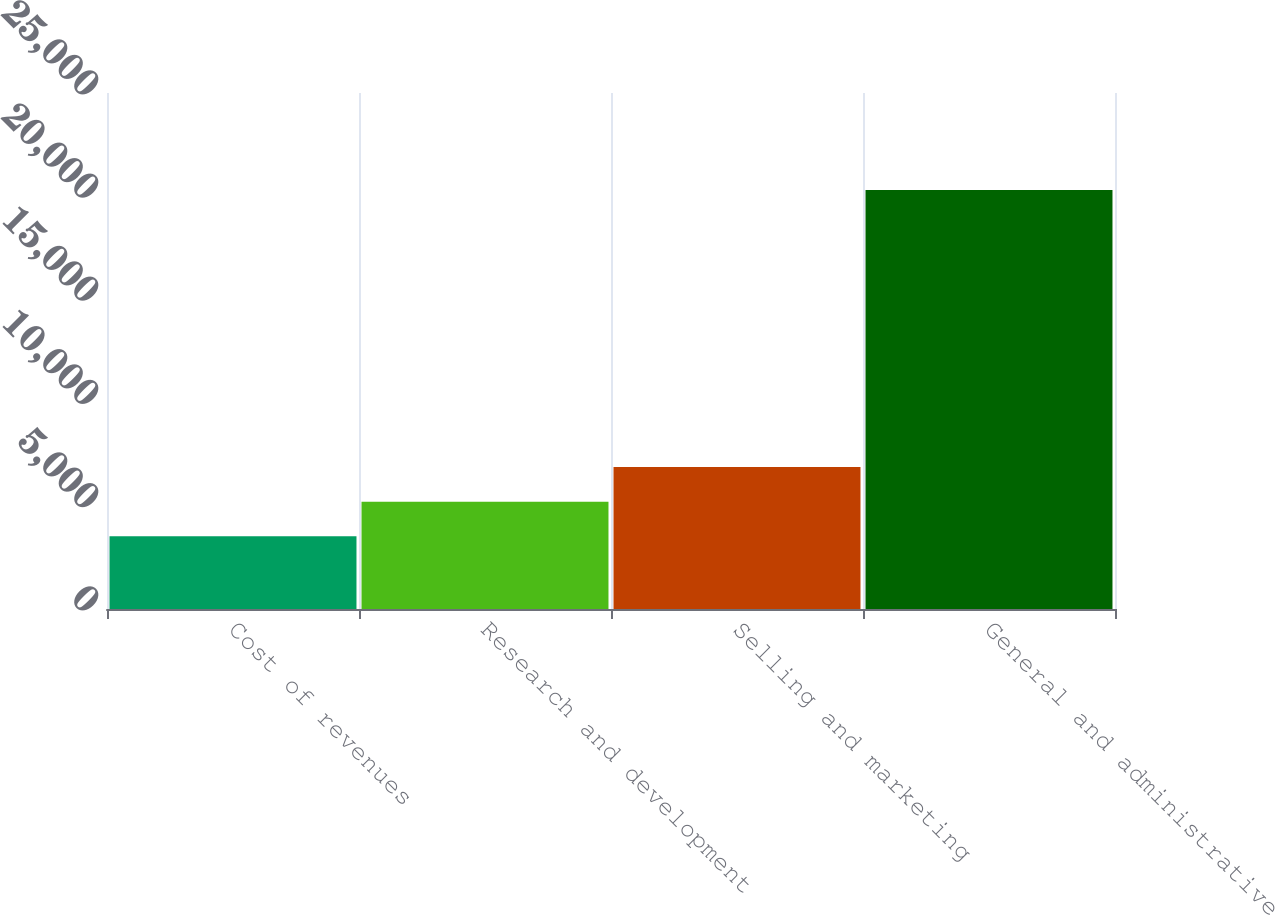Convert chart to OTSL. <chart><loc_0><loc_0><loc_500><loc_500><bar_chart><fcel>Cost of revenues<fcel>Research and development<fcel>Selling and marketing<fcel>General and administrative<nl><fcel>3522<fcel>5199.4<fcel>6876.8<fcel>20296<nl></chart> 